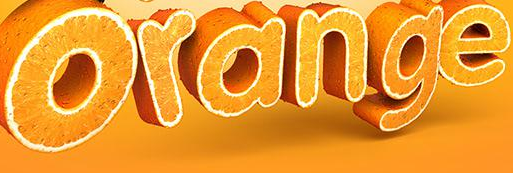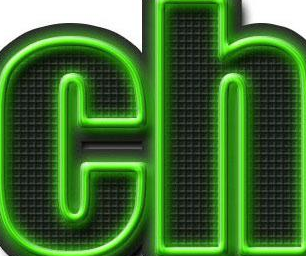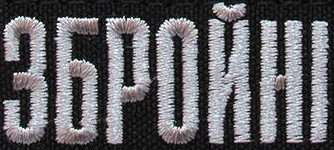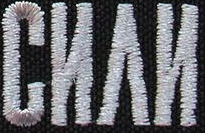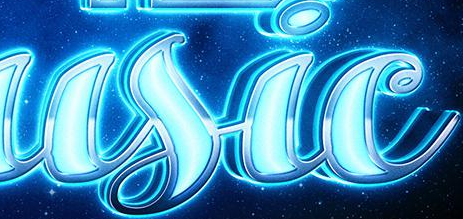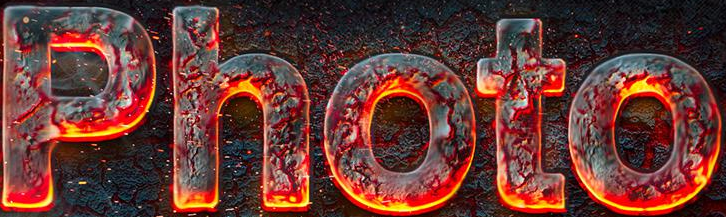What text is displayed in these images sequentially, separated by a semicolon? Orange; ch; ЗБPOЙHI; CИΛИ; usic; Photo 